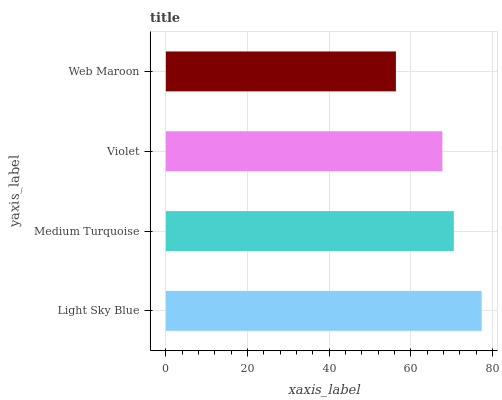Is Web Maroon the minimum?
Answer yes or no. Yes. Is Light Sky Blue the maximum?
Answer yes or no. Yes. Is Medium Turquoise the minimum?
Answer yes or no. No. Is Medium Turquoise the maximum?
Answer yes or no. No. Is Light Sky Blue greater than Medium Turquoise?
Answer yes or no. Yes. Is Medium Turquoise less than Light Sky Blue?
Answer yes or no. Yes. Is Medium Turquoise greater than Light Sky Blue?
Answer yes or no. No. Is Light Sky Blue less than Medium Turquoise?
Answer yes or no. No. Is Medium Turquoise the high median?
Answer yes or no. Yes. Is Violet the low median?
Answer yes or no. Yes. Is Light Sky Blue the high median?
Answer yes or no. No. Is Medium Turquoise the low median?
Answer yes or no. No. 